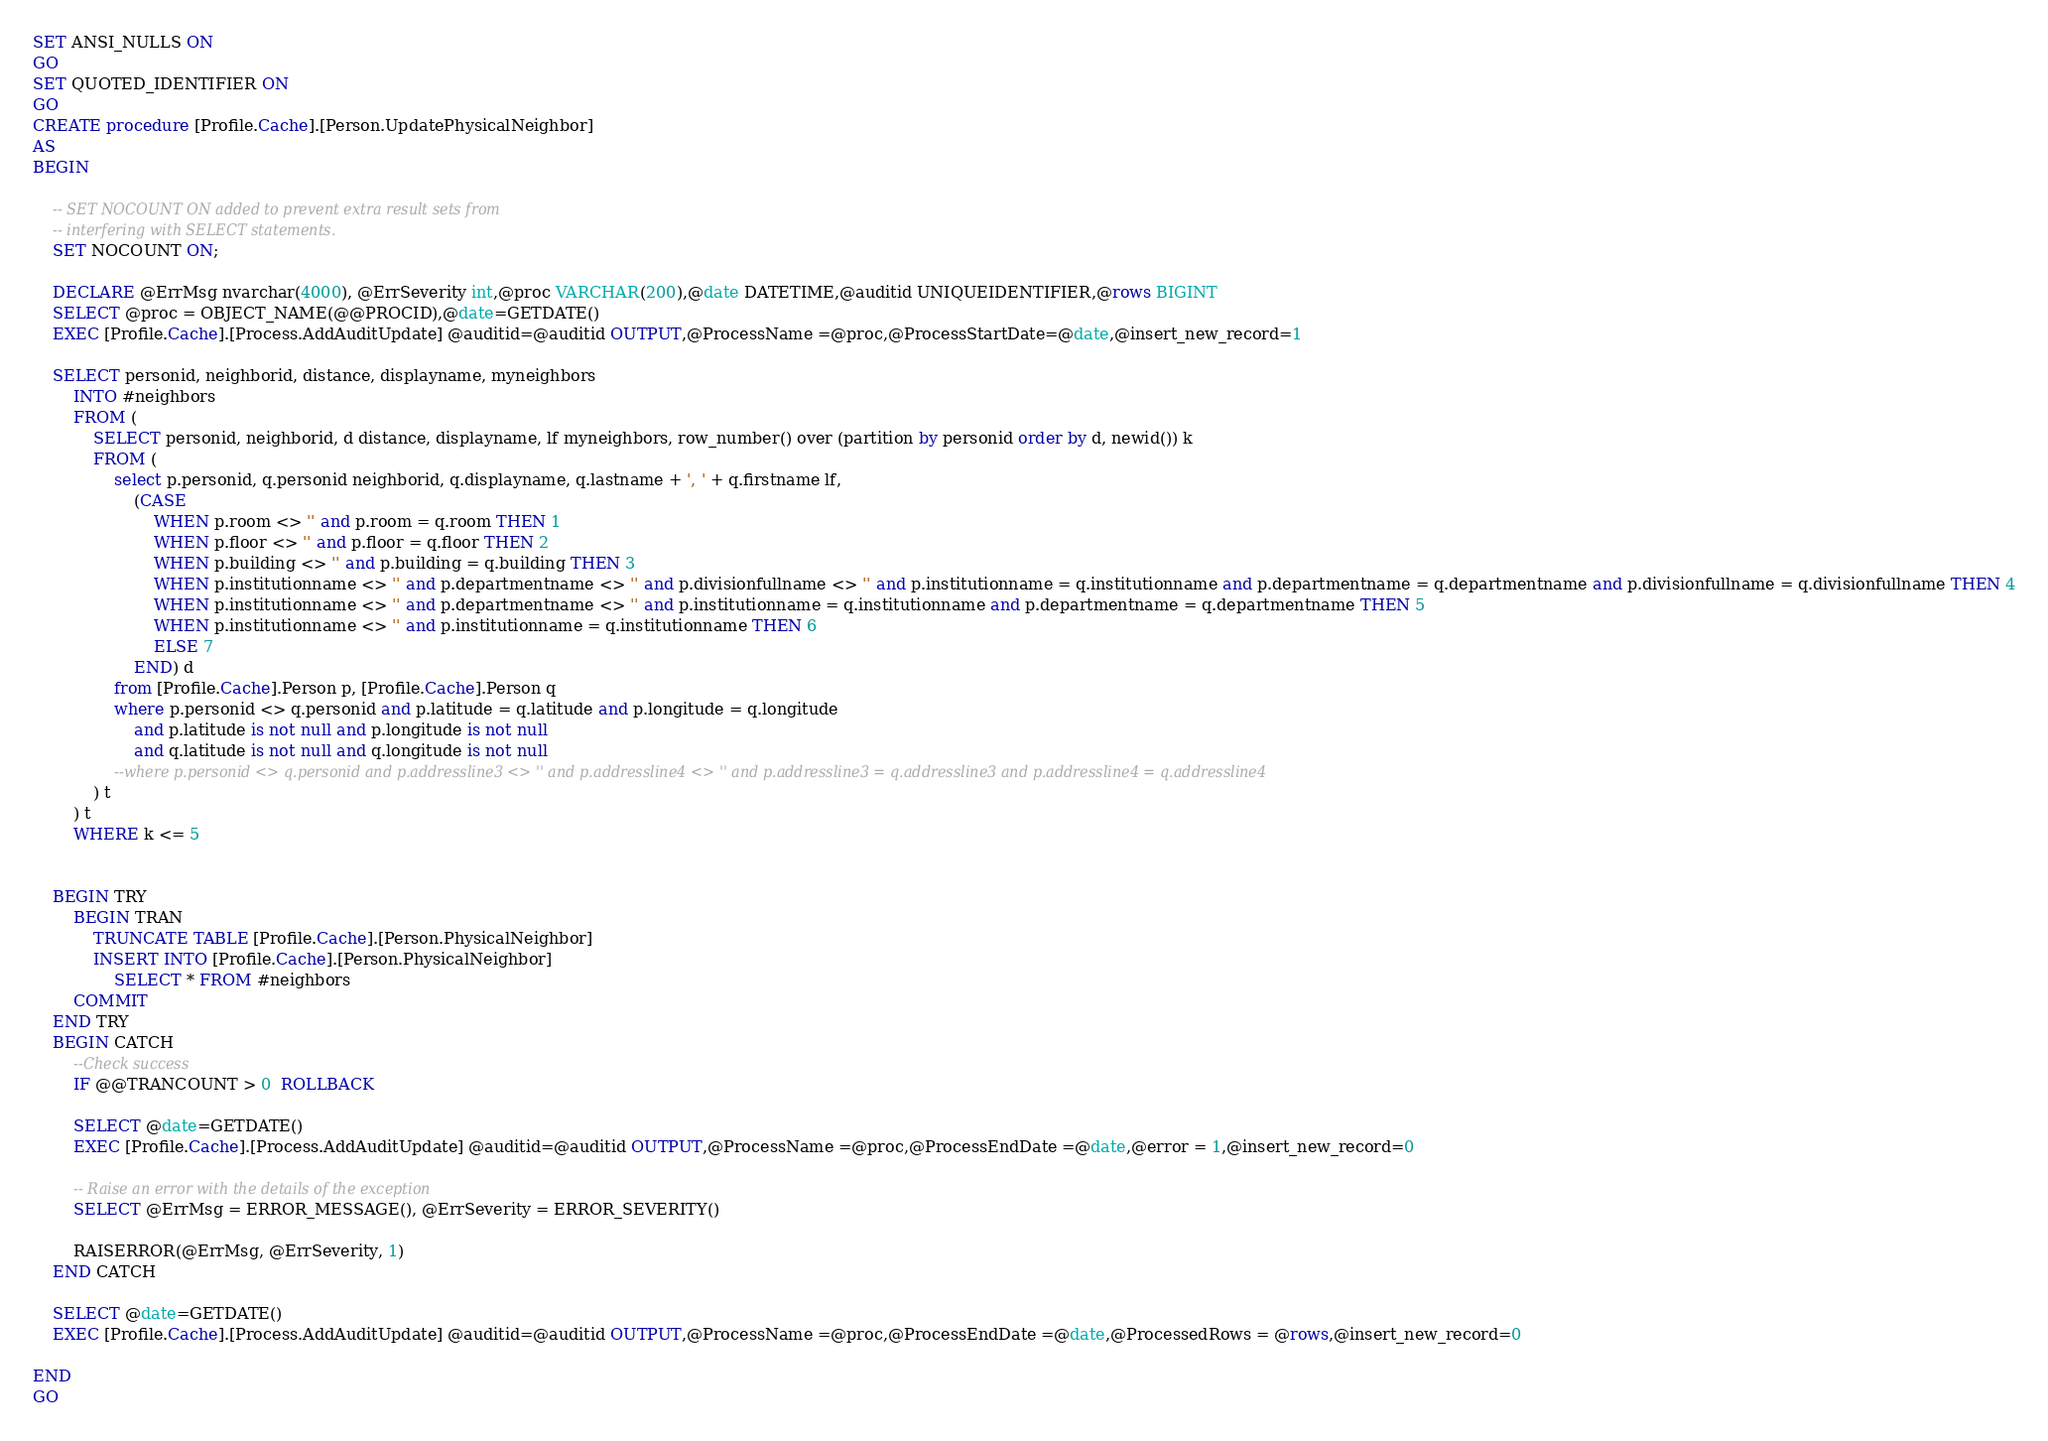Convert code to text. <code><loc_0><loc_0><loc_500><loc_500><_SQL_>SET ANSI_NULLS ON
GO
SET QUOTED_IDENTIFIER ON
GO
CREATE procedure [Profile.Cache].[Person.UpdatePhysicalNeighbor]
AS
BEGIN
 
	-- SET NOCOUNT ON added to prevent extra result sets from
	-- interfering with SELECT statements.
	SET NOCOUNT ON;
 
	DECLARE @ErrMsg nvarchar(4000), @ErrSeverity int,@proc VARCHAR(200),@date DATETIME,@auditid UNIQUEIDENTIFIER,@rows BIGINT 
	SELECT @proc = OBJECT_NAME(@@PROCID),@date=GETDATE() 	
	EXEC [Profile.Cache].[Process.AddAuditUpdate] @auditid=@auditid OUTPUT,@ProcessName =@proc,@ProcessStartDate=@date,@insert_new_record=1
 
	SELECT personid, neighborid, distance, displayname, myneighbors
		INTO #neighbors
		FROM (
			SELECT personid, neighborid, d distance, displayname, lf myneighbors, row_number() over (partition by personid order by d, newid()) k
			FROM (
				select p.personid, q.personid neighborid, q.displayname, q.lastname + ', ' + q.firstname lf,
					(CASE
						WHEN p.room <> '' and p.room = q.room THEN 1
						WHEN p.floor <> '' and p.floor = q.floor THEN 2
						WHEN p.building <> '' and p.building = q.building THEN 3
						WHEN p.institutionname <> '' and p.departmentname <> '' and p.divisionfullname <> '' and p.institutionname = q.institutionname and p.departmentname = q.departmentname and p.divisionfullname = q.divisionfullname THEN 4
						WHEN p.institutionname <> '' and p.departmentname <> '' and p.institutionname = q.institutionname and p.departmentname = q.departmentname THEN 5
						WHEN p.institutionname <> '' and p.institutionname = q.institutionname THEN 6
						ELSE 7
					END) d
				from [Profile.Cache].Person p, [Profile.Cache].Person q
				where p.personid <> q.personid and p.latitude = q.latitude and p.longitude = q.longitude 
					and p.latitude is not null and p.longitude is not null
					and q.latitude is not null and q.longitude is not null
				--where p.personid <> q.personid and p.addressline3 <> '' and p.addressline4 <> '' and p.addressline3 = q.addressline3 and p.addressline4 = q.addressline4
			) t
		) t
		WHERE k <= 5
 
 
	BEGIN TRY
		BEGIN TRAN
			TRUNCATE TABLE [Profile.Cache].[Person.PhysicalNeighbor]
			INSERT INTO [Profile.Cache].[Person.PhysicalNeighbor]
				SELECT * FROM #neighbors
		COMMIT
	END TRY
	BEGIN CATCH
		--Check success
		IF @@TRANCOUNT > 0  ROLLBACK
 
		SELECT @date=GETDATE()
		EXEC [Profile.Cache].[Process.AddAuditUpdate] @auditid=@auditid OUTPUT,@ProcessName =@proc,@ProcessEndDate =@date,@error = 1,@insert_new_record=0
 
		-- Raise an error with the details of the exception
		SELECT @ErrMsg = ERROR_MESSAGE(), @ErrSeverity = ERROR_SEVERITY()
 
		RAISERROR(@ErrMsg, @ErrSeverity, 1)
	END CATCH
 
	SELECT @date=GETDATE()
	EXEC [Profile.Cache].[Process.AddAuditUpdate] @auditid=@auditid OUTPUT,@ProcessName =@proc,@ProcessEndDate =@date,@ProcessedRows = @rows,@insert_new_record=0
 
END
GO
</code> 